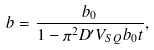Convert formula to latex. <formula><loc_0><loc_0><loc_500><loc_500>b = \frac { b _ { 0 } } { 1 - \pi ^ { 2 } D ^ { \prime } V _ { S Q } b _ { 0 } t } ,</formula> 